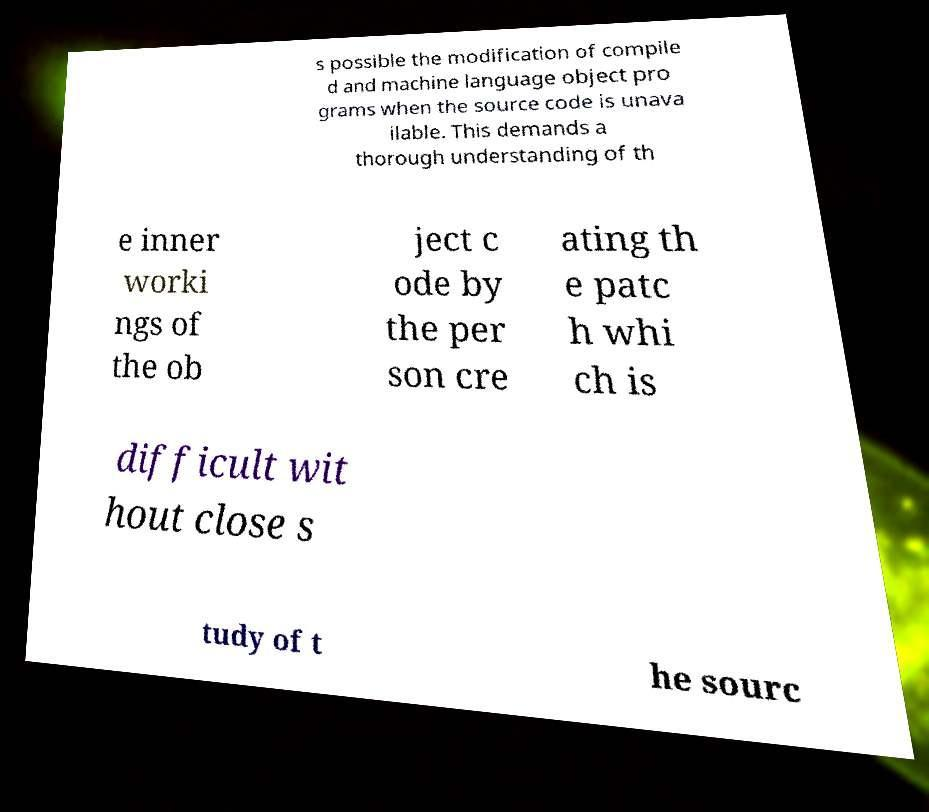Could you extract and type out the text from this image? s possible the modification of compile d and machine language object pro grams when the source code is unava ilable. This demands a thorough understanding of th e inner worki ngs of the ob ject c ode by the per son cre ating th e patc h whi ch is difficult wit hout close s tudy of t he sourc 